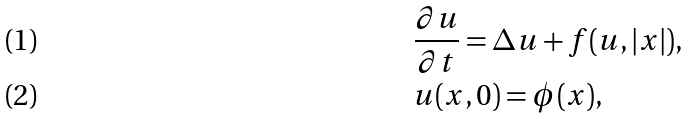<formula> <loc_0><loc_0><loc_500><loc_500>& \frac { \partial u } { \partial t } = \Delta u + f ( u , | x | ) , \\ & u ( x , 0 ) = \phi ( x ) ,</formula> 